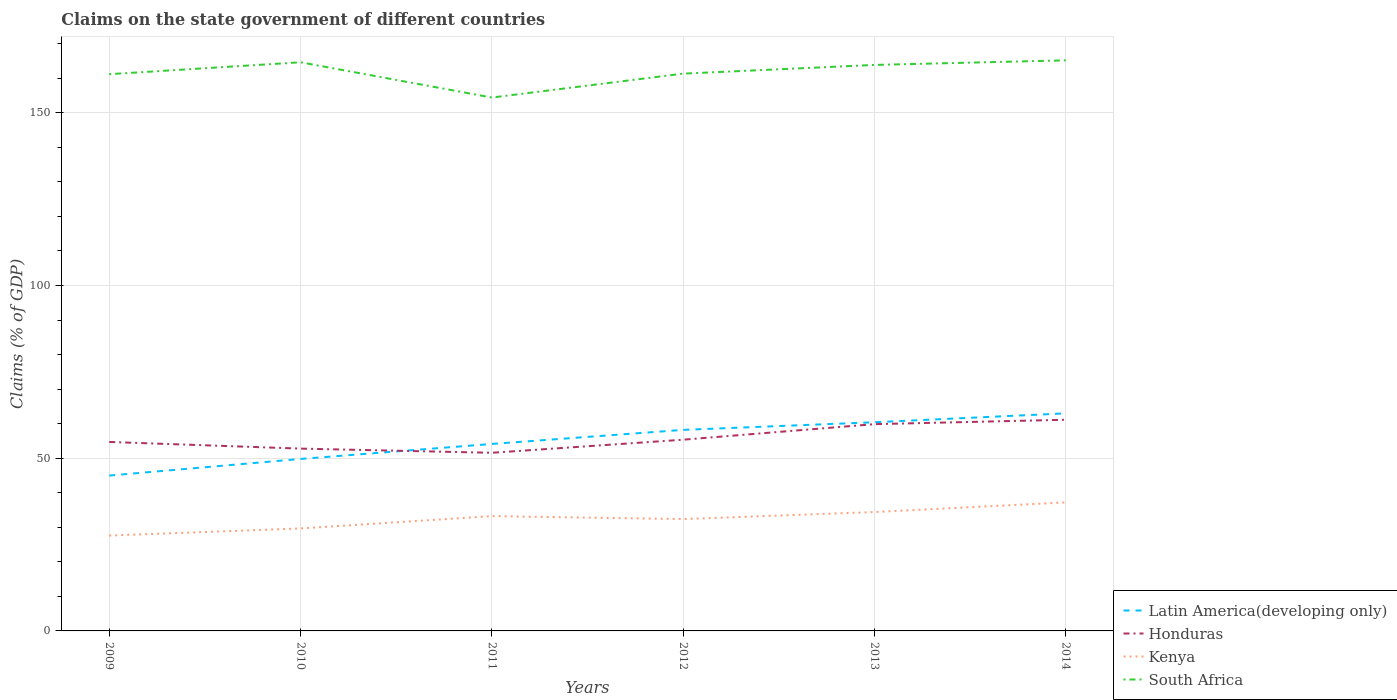How many different coloured lines are there?
Your answer should be compact. 4. Across all years, what is the maximum percentage of GDP claimed on the state government in Kenya?
Your answer should be very brief. 27.61. What is the total percentage of GDP claimed on the state government in Honduras in the graph?
Make the answer very short. -3.79. What is the difference between the highest and the second highest percentage of GDP claimed on the state government in Latin America(developing only)?
Provide a short and direct response. 18.01. What is the difference between the highest and the lowest percentage of GDP claimed on the state government in Latin America(developing only)?
Make the answer very short. 3. How many years are there in the graph?
Your answer should be compact. 6. Does the graph contain grids?
Offer a very short reply. Yes. Where does the legend appear in the graph?
Give a very brief answer. Bottom right. How are the legend labels stacked?
Provide a succinct answer. Vertical. What is the title of the graph?
Make the answer very short. Claims on the state government of different countries. What is the label or title of the X-axis?
Provide a succinct answer. Years. What is the label or title of the Y-axis?
Provide a succinct answer. Claims (% of GDP). What is the Claims (% of GDP) in Latin America(developing only) in 2009?
Provide a short and direct response. 44.98. What is the Claims (% of GDP) of Honduras in 2009?
Keep it short and to the point. 54.71. What is the Claims (% of GDP) of Kenya in 2009?
Keep it short and to the point. 27.61. What is the Claims (% of GDP) of South Africa in 2009?
Provide a short and direct response. 161.18. What is the Claims (% of GDP) in Latin America(developing only) in 2010?
Your answer should be compact. 49.79. What is the Claims (% of GDP) of Honduras in 2010?
Offer a terse response. 52.78. What is the Claims (% of GDP) in Kenya in 2010?
Provide a succinct answer. 29.66. What is the Claims (% of GDP) in South Africa in 2010?
Your answer should be very brief. 164.63. What is the Claims (% of GDP) of Latin America(developing only) in 2011?
Keep it short and to the point. 54.13. What is the Claims (% of GDP) of Honduras in 2011?
Keep it short and to the point. 51.57. What is the Claims (% of GDP) in Kenya in 2011?
Give a very brief answer. 33.23. What is the Claims (% of GDP) of South Africa in 2011?
Provide a short and direct response. 154.42. What is the Claims (% of GDP) in Latin America(developing only) in 2012?
Ensure brevity in your answer.  58.21. What is the Claims (% of GDP) in Honduras in 2012?
Keep it short and to the point. 55.36. What is the Claims (% of GDP) in Kenya in 2012?
Your answer should be compact. 32.39. What is the Claims (% of GDP) of South Africa in 2012?
Offer a terse response. 161.34. What is the Claims (% of GDP) in Latin America(developing only) in 2013?
Keep it short and to the point. 60.41. What is the Claims (% of GDP) in Honduras in 2013?
Your answer should be compact. 59.86. What is the Claims (% of GDP) of Kenya in 2013?
Your response must be concise. 34.42. What is the Claims (% of GDP) of South Africa in 2013?
Your response must be concise. 163.86. What is the Claims (% of GDP) of Latin America(developing only) in 2014?
Your response must be concise. 62.99. What is the Claims (% of GDP) in Honduras in 2014?
Make the answer very short. 61.14. What is the Claims (% of GDP) in Kenya in 2014?
Offer a terse response. 37.21. What is the Claims (% of GDP) in South Africa in 2014?
Your answer should be very brief. 165.19. Across all years, what is the maximum Claims (% of GDP) of Latin America(developing only)?
Keep it short and to the point. 62.99. Across all years, what is the maximum Claims (% of GDP) of Honduras?
Provide a succinct answer. 61.14. Across all years, what is the maximum Claims (% of GDP) of Kenya?
Offer a terse response. 37.21. Across all years, what is the maximum Claims (% of GDP) of South Africa?
Make the answer very short. 165.19. Across all years, what is the minimum Claims (% of GDP) of Latin America(developing only)?
Offer a very short reply. 44.98. Across all years, what is the minimum Claims (% of GDP) in Honduras?
Provide a succinct answer. 51.57. Across all years, what is the minimum Claims (% of GDP) of Kenya?
Your response must be concise. 27.61. Across all years, what is the minimum Claims (% of GDP) of South Africa?
Offer a terse response. 154.42. What is the total Claims (% of GDP) in Latin America(developing only) in the graph?
Keep it short and to the point. 330.51. What is the total Claims (% of GDP) of Honduras in the graph?
Your answer should be very brief. 335.43. What is the total Claims (% of GDP) in Kenya in the graph?
Offer a very short reply. 194.53. What is the total Claims (% of GDP) of South Africa in the graph?
Give a very brief answer. 970.63. What is the difference between the Claims (% of GDP) in Latin America(developing only) in 2009 and that in 2010?
Provide a succinct answer. -4.81. What is the difference between the Claims (% of GDP) in Honduras in 2009 and that in 2010?
Your response must be concise. 1.93. What is the difference between the Claims (% of GDP) in Kenya in 2009 and that in 2010?
Give a very brief answer. -2.05. What is the difference between the Claims (% of GDP) in South Africa in 2009 and that in 2010?
Your response must be concise. -3.45. What is the difference between the Claims (% of GDP) in Latin America(developing only) in 2009 and that in 2011?
Provide a short and direct response. -9.15. What is the difference between the Claims (% of GDP) of Honduras in 2009 and that in 2011?
Your response must be concise. 3.14. What is the difference between the Claims (% of GDP) of Kenya in 2009 and that in 2011?
Your answer should be compact. -5.62. What is the difference between the Claims (% of GDP) of South Africa in 2009 and that in 2011?
Provide a short and direct response. 6.76. What is the difference between the Claims (% of GDP) of Latin America(developing only) in 2009 and that in 2012?
Offer a very short reply. -13.23. What is the difference between the Claims (% of GDP) in Honduras in 2009 and that in 2012?
Ensure brevity in your answer.  -0.65. What is the difference between the Claims (% of GDP) of Kenya in 2009 and that in 2012?
Offer a very short reply. -4.78. What is the difference between the Claims (% of GDP) of South Africa in 2009 and that in 2012?
Make the answer very short. -0.16. What is the difference between the Claims (% of GDP) in Latin America(developing only) in 2009 and that in 2013?
Ensure brevity in your answer.  -15.43. What is the difference between the Claims (% of GDP) of Honduras in 2009 and that in 2013?
Your answer should be compact. -5.16. What is the difference between the Claims (% of GDP) in Kenya in 2009 and that in 2013?
Make the answer very short. -6.81. What is the difference between the Claims (% of GDP) of South Africa in 2009 and that in 2013?
Give a very brief answer. -2.68. What is the difference between the Claims (% of GDP) of Latin America(developing only) in 2009 and that in 2014?
Your response must be concise. -18.01. What is the difference between the Claims (% of GDP) in Honduras in 2009 and that in 2014?
Your response must be concise. -6.43. What is the difference between the Claims (% of GDP) of Kenya in 2009 and that in 2014?
Your answer should be compact. -9.6. What is the difference between the Claims (% of GDP) in South Africa in 2009 and that in 2014?
Provide a succinct answer. -4.01. What is the difference between the Claims (% of GDP) in Latin America(developing only) in 2010 and that in 2011?
Ensure brevity in your answer.  -4.34. What is the difference between the Claims (% of GDP) in Honduras in 2010 and that in 2011?
Keep it short and to the point. 1.21. What is the difference between the Claims (% of GDP) in Kenya in 2010 and that in 2011?
Your response must be concise. -3.57. What is the difference between the Claims (% of GDP) of South Africa in 2010 and that in 2011?
Your answer should be compact. 10.21. What is the difference between the Claims (% of GDP) of Latin America(developing only) in 2010 and that in 2012?
Provide a succinct answer. -8.42. What is the difference between the Claims (% of GDP) of Honduras in 2010 and that in 2012?
Your answer should be compact. -2.58. What is the difference between the Claims (% of GDP) of Kenya in 2010 and that in 2012?
Your answer should be compact. -2.72. What is the difference between the Claims (% of GDP) in South Africa in 2010 and that in 2012?
Your response must be concise. 3.29. What is the difference between the Claims (% of GDP) in Latin America(developing only) in 2010 and that in 2013?
Offer a terse response. -10.63. What is the difference between the Claims (% of GDP) in Honduras in 2010 and that in 2013?
Ensure brevity in your answer.  -7.08. What is the difference between the Claims (% of GDP) in Kenya in 2010 and that in 2013?
Your answer should be compact. -4.75. What is the difference between the Claims (% of GDP) of South Africa in 2010 and that in 2013?
Provide a succinct answer. 0.77. What is the difference between the Claims (% of GDP) in Latin America(developing only) in 2010 and that in 2014?
Provide a short and direct response. -13.2. What is the difference between the Claims (% of GDP) in Honduras in 2010 and that in 2014?
Keep it short and to the point. -8.35. What is the difference between the Claims (% of GDP) in Kenya in 2010 and that in 2014?
Provide a short and direct response. -7.55. What is the difference between the Claims (% of GDP) in South Africa in 2010 and that in 2014?
Keep it short and to the point. -0.56. What is the difference between the Claims (% of GDP) of Latin America(developing only) in 2011 and that in 2012?
Ensure brevity in your answer.  -4.07. What is the difference between the Claims (% of GDP) in Honduras in 2011 and that in 2012?
Keep it short and to the point. -3.79. What is the difference between the Claims (% of GDP) of Kenya in 2011 and that in 2012?
Ensure brevity in your answer.  0.85. What is the difference between the Claims (% of GDP) of South Africa in 2011 and that in 2012?
Provide a short and direct response. -6.92. What is the difference between the Claims (% of GDP) in Latin America(developing only) in 2011 and that in 2013?
Offer a terse response. -6.28. What is the difference between the Claims (% of GDP) in Honduras in 2011 and that in 2013?
Ensure brevity in your answer.  -8.29. What is the difference between the Claims (% of GDP) in Kenya in 2011 and that in 2013?
Make the answer very short. -1.19. What is the difference between the Claims (% of GDP) of South Africa in 2011 and that in 2013?
Offer a terse response. -9.44. What is the difference between the Claims (% of GDP) in Latin America(developing only) in 2011 and that in 2014?
Offer a terse response. -8.86. What is the difference between the Claims (% of GDP) of Honduras in 2011 and that in 2014?
Make the answer very short. -9.56. What is the difference between the Claims (% of GDP) in Kenya in 2011 and that in 2014?
Provide a short and direct response. -3.98. What is the difference between the Claims (% of GDP) in South Africa in 2011 and that in 2014?
Your answer should be very brief. -10.77. What is the difference between the Claims (% of GDP) of Latin America(developing only) in 2012 and that in 2013?
Your answer should be very brief. -2.21. What is the difference between the Claims (% of GDP) in Honduras in 2012 and that in 2013?
Offer a terse response. -4.51. What is the difference between the Claims (% of GDP) of Kenya in 2012 and that in 2013?
Your answer should be very brief. -2.03. What is the difference between the Claims (% of GDP) in South Africa in 2012 and that in 2013?
Your answer should be compact. -2.52. What is the difference between the Claims (% of GDP) of Latin America(developing only) in 2012 and that in 2014?
Your response must be concise. -4.78. What is the difference between the Claims (% of GDP) in Honduras in 2012 and that in 2014?
Offer a very short reply. -5.78. What is the difference between the Claims (% of GDP) of Kenya in 2012 and that in 2014?
Ensure brevity in your answer.  -4.83. What is the difference between the Claims (% of GDP) of South Africa in 2012 and that in 2014?
Ensure brevity in your answer.  -3.85. What is the difference between the Claims (% of GDP) of Latin America(developing only) in 2013 and that in 2014?
Provide a succinct answer. -2.58. What is the difference between the Claims (% of GDP) of Honduras in 2013 and that in 2014?
Give a very brief answer. -1.27. What is the difference between the Claims (% of GDP) in Kenya in 2013 and that in 2014?
Give a very brief answer. -2.79. What is the difference between the Claims (% of GDP) of South Africa in 2013 and that in 2014?
Give a very brief answer. -1.33. What is the difference between the Claims (% of GDP) in Latin America(developing only) in 2009 and the Claims (% of GDP) in Honduras in 2010?
Make the answer very short. -7.8. What is the difference between the Claims (% of GDP) in Latin America(developing only) in 2009 and the Claims (% of GDP) in Kenya in 2010?
Ensure brevity in your answer.  15.32. What is the difference between the Claims (% of GDP) of Latin America(developing only) in 2009 and the Claims (% of GDP) of South Africa in 2010?
Your response must be concise. -119.65. What is the difference between the Claims (% of GDP) in Honduras in 2009 and the Claims (% of GDP) in Kenya in 2010?
Your answer should be compact. 25.05. What is the difference between the Claims (% of GDP) in Honduras in 2009 and the Claims (% of GDP) in South Africa in 2010?
Give a very brief answer. -109.92. What is the difference between the Claims (% of GDP) in Kenya in 2009 and the Claims (% of GDP) in South Africa in 2010?
Provide a short and direct response. -137.02. What is the difference between the Claims (% of GDP) of Latin America(developing only) in 2009 and the Claims (% of GDP) of Honduras in 2011?
Give a very brief answer. -6.59. What is the difference between the Claims (% of GDP) of Latin America(developing only) in 2009 and the Claims (% of GDP) of Kenya in 2011?
Provide a short and direct response. 11.75. What is the difference between the Claims (% of GDP) of Latin America(developing only) in 2009 and the Claims (% of GDP) of South Africa in 2011?
Provide a succinct answer. -109.44. What is the difference between the Claims (% of GDP) in Honduras in 2009 and the Claims (% of GDP) in Kenya in 2011?
Give a very brief answer. 21.48. What is the difference between the Claims (% of GDP) of Honduras in 2009 and the Claims (% of GDP) of South Africa in 2011?
Offer a very short reply. -99.71. What is the difference between the Claims (% of GDP) of Kenya in 2009 and the Claims (% of GDP) of South Africa in 2011?
Ensure brevity in your answer.  -126.81. What is the difference between the Claims (% of GDP) in Latin America(developing only) in 2009 and the Claims (% of GDP) in Honduras in 2012?
Make the answer very short. -10.38. What is the difference between the Claims (% of GDP) in Latin America(developing only) in 2009 and the Claims (% of GDP) in Kenya in 2012?
Offer a very short reply. 12.59. What is the difference between the Claims (% of GDP) of Latin America(developing only) in 2009 and the Claims (% of GDP) of South Africa in 2012?
Your answer should be very brief. -116.36. What is the difference between the Claims (% of GDP) in Honduras in 2009 and the Claims (% of GDP) in Kenya in 2012?
Provide a short and direct response. 22.32. What is the difference between the Claims (% of GDP) in Honduras in 2009 and the Claims (% of GDP) in South Africa in 2012?
Make the answer very short. -106.63. What is the difference between the Claims (% of GDP) in Kenya in 2009 and the Claims (% of GDP) in South Africa in 2012?
Offer a terse response. -133.73. What is the difference between the Claims (% of GDP) of Latin America(developing only) in 2009 and the Claims (% of GDP) of Honduras in 2013?
Keep it short and to the point. -14.89. What is the difference between the Claims (% of GDP) in Latin America(developing only) in 2009 and the Claims (% of GDP) in Kenya in 2013?
Your answer should be very brief. 10.56. What is the difference between the Claims (% of GDP) of Latin America(developing only) in 2009 and the Claims (% of GDP) of South Africa in 2013?
Make the answer very short. -118.88. What is the difference between the Claims (% of GDP) in Honduras in 2009 and the Claims (% of GDP) in Kenya in 2013?
Provide a short and direct response. 20.29. What is the difference between the Claims (% of GDP) in Honduras in 2009 and the Claims (% of GDP) in South Africa in 2013?
Offer a terse response. -109.15. What is the difference between the Claims (% of GDP) of Kenya in 2009 and the Claims (% of GDP) of South Africa in 2013?
Keep it short and to the point. -136.25. What is the difference between the Claims (% of GDP) of Latin America(developing only) in 2009 and the Claims (% of GDP) of Honduras in 2014?
Your answer should be compact. -16.16. What is the difference between the Claims (% of GDP) of Latin America(developing only) in 2009 and the Claims (% of GDP) of Kenya in 2014?
Provide a succinct answer. 7.77. What is the difference between the Claims (% of GDP) of Latin America(developing only) in 2009 and the Claims (% of GDP) of South Africa in 2014?
Your answer should be compact. -120.21. What is the difference between the Claims (% of GDP) of Honduras in 2009 and the Claims (% of GDP) of Kenya in 2014?
Your response must be concise. 17.5. What is the difference between the Claims (% of GDP) of Honduras in 2009 and the Claims (% of GDP) of South Africa in 2014?
Keep it short and to the point. -110.48. What is the difference between the Claims (% of GDP) in Kenya in 2009 and the Claims (% of GDP) in South Africa in 2014?
Your response must be concise. -137.58. What is the difference between the Claims (% of GDP) in Latin America(developing only) in 2010 and the Claims (% of GDP) in Honduras in 2011?
Keep it short and to the point. -1.79. What is the difference between the Claims (% of GDP) in Latin America(developing only) in 2010 and the Claims (% of GDP) in Kenya in 2011?
Make the answer very short. 16.56. What is the difference between the Claims (% of GDP) in Latin America(developing only) in 2010 and the Claims (% of GDP) in South Africa in 2011?
Your answer should be very brief. -104.63. What is the difference between the Claims (% of GDP) of Honduras in 2010 and the Claims (% of GDP) of Kenya in 2011?
Your response must be concise. 19.55. What is the difference between the Claims (% of GDP) in Honduras in 2010 and the Claims (% of GDP) in South Africa in 2011?
Your answer should be very brief. -101.64. What is the difference between the Claims (% of GDP) in Kenya in 2010 and the Claims (% of GDP) in South Africa in 2011?
Offer a very short reply. -124.75. What is the difference between the Claims (% of GDP) in Latin America(developing only) in 2010 and the Claims (% of GDP) in Honduras in 2012?
Your answer should be compact. -5.57. What is the difference between the Claims (% of GDP) in Latin America(developing only) in 2010 and the Claims (% of GDP) in Kenya in 2012?
Offer a terse response. 17.4. What is the difference between the Claims (% of GDP) in Latin America(developing only) in 2010 and the Claims (% of GDP) in South Africa in 2012?
Your response must be concise. -111.55. What is the difference between the Claims (% of GDP) of Honduras in 2010 and the Claims (% of GDP) of Kenya in 2012?
Your answer should be very brief. 20.4. What is the difference between the Claims (% of GDP) in Honduras in 2010 and the Claims (% of GDP) in South Africa in 2012?
Make the answer very short. -108.56. What is the difference between the Claims (% of GDP) of Kenya in 2010 and the Claims (% of GDP) of South Africa in 2012?
Provide a succinct answer. -131.67. What is the difference between the Claims (% of GDP) in Latin America(developing only) in 2010 and the Claims (% of GDP) in Honduras in 2013?
Offer a very short reply. -10.08. What is the difference between the Claims (% of GDP) in Latin America(developing only) in 2010 and the Claims (% of GDP) in Kenya in 2013?
Ensure brevity in your answer.  15.37. What is the difference between the Claims (% of GDP) of Latin America(developing only) in 2010 and the Claims (% of GDP) of South Africa in 2013?
Make the answer very short. -114.08. What is the difference between the Claims (% of GDP) in Honduras in 2010 and the Claims (% of GDP) in Kenya in 2013?
Provide a short and direct response. 18.36. What is the difference between the Claims (% of GDP) in Honduras in 2010 and the Claims (% of GDP) in South Africa in 2013?
Your answer should be very brief. -111.08. What is the difference between the Claims (% of GDP) of Kenya in 2010 and the Claims (% of GDP) of South Africa in 2013?
Offer a terse response. -134.2. What is the difference between the Claims (% of GDP) in Latin America(developing only) in 2010 and the Claims (% of GDP) in Honduras in 2014?
Your answer should be compact. -11.35. What is the difference between the Claims (% of GDP) of Latin America(developing only) in 2010 and the Claims (% of GDP) of Kenya in 2014?
Offer a terse response. 12.58. What is the difference between the Claims (% of GDP) of Latin America(developing only) in 2010 and the Claims (% of GDP) of South Africa in 2014?
Offer a terse response. -115.4. What is the difference between the Claims (% of GDP) of Honduras in 2010 and the Claims (% of GDP) of Kenya in 2014?
Ensure brevity in your answer.  15.57. What is the difference between the Claims (% of GDP) in Honduras in 2010 and the Claims (% of GDP) in South Africa in 2014?
Give a very brief answer. -112.41. What is the difference between the Claims (% of GDP) in Kenya in 2010 and the Claims (% of GDP) in South Africa in 2014?
Your answer should be very brief. -135.53. What is the difference between the Claims (% of GDP) of Latin America(developing only) in 2011 and the Claims (% of GDP) of Honduras in 2012?
Your response must be concise. -1.23. What is the difference between the Claims (% of GDP) in Latin America(developing only) in 2011 and the Claims (% of GDP) in Kenya in 2012?
Your answer should be very brief. 21.75. What is the difference between the Claims (% of GDP) in Latin America(developing only) in 2011 and the Claims (% of GDP) in South Africa in 2012?
Your answer should be very brief. -107.21. What is the difference between the Claims (% of GDP) of Honduras in 2011 and the Claims (% of GDP) of Kenya in 2012?
Give a very brief answer. 19.19. What is the difference between the Claims (% of GDP) of Honduras in 2011 and the Claims (% of GDP) of South Africa in 2012?
Offer a terse response. -109.76. What is the difference between the Claims (% of GDP) of Kenya in 2011 and the Claims (% of GDP) of South Africa in 2012?
Give a very brief answer. -128.11. What is the difference between the Claims (% of GDP) in Latin America(developing only) in 2011 and the Claims (% of GDP) in Honduras in 2013?
Give a very brief answer. -5.73. What is the difference between the Claims (% of GDP) in Latin America(developing only) in 2011 and the Claims (% of GDP) in Kenya in 2013?
Give a very brief answer. 19.71. What is the difference between the Claims (% of GDP) in Latin America(developing only) in 2011 and the Claims (% of GDP) in South Africa in 2013?
Provide a succinct answer. -109.73. What is the difference between the Claims (% of GDP) in Honduras in 2011 and the Claims (% of GDP) in Kenya in 2013?
Provide a succinct answer. 17.16. What is the difference between the Claims (% of GDP) of Honduras in 2011 and the Claims (% of GDP) of South Africa in 2013?
Your response must be concise. -112.29. What is the difference between the Claims (% of GDP) in Kenya in 2011 and the Claims (% of GDP) in South Africa in 2013?
Give a very brief answer. -130.63. What is the difference between the Claims (% of GDP) in Latin America(developing only) in 2011 and the Claims (% of GDP) in Honduras in 2014?
Provide a succinct answer. -7. What is the difference between the Claims (% of GDP) of Latin America(developing only) in 2011 and the Claims (% of GDP) of Kenya in 2014?
Give a very brief answer. 16.92. What is the difference between the Claims (% of GDP) in Latin America(developing only) in 2011 and the Claims (% of GDP) in South Africa in 2014?
Your response must be concise. -111.06. What is the difference between the Claims (% of GDP) in Honduras in 2011 and the Claims (% of GDP) in Kenya in 2014?
Give a very brief answer. 14.36. What is the difference between the Claims (% of GDP) of Honduras in 2011 and the Claims (% of GDP) of South Africa in 2014?
Give a very brief answer. -113.62. What is the difference between the Claims (% of GDP) in Kenya in 2011 and the Claims (% of GDP) in South Africa in 2014?
Your answer should be very brief. -131.96. What is the difference between the Claims (% of GDP) in Latin America(developing only) in 2012 and the Claims (% of GDP) in Honduras in 2013?
Provide a short and direct response. -1.66. What is the difference between the Claims (% of GDP) in Latin America(developing only) in 2012 and the Claims (% of GDP) in Kenya in 2013?
Give a very brief answer. 23.79. What is the difference between the Claims (% of GDP) of Latin America(developing only) in 2012 and the Claims (% of GDP) of South Africa in 2013?
Ensure brevity in your answer.  -105.66. What is the difference between the Claims (% of GDP) of Honduras in 2012 and the Claims (% of GDP) of Kenya in 2013?
Keep it short and to the point. 20.94. What is the difference between the Claims (% of GDP) of Honduras in 2012 and the Claims (% of GDP) of South Africa in 2013?
Your answer should be very brief. -108.5. What is the difference between the Claims (% of GDP) in Kenya in 2012 and the Claims (% of GDP) in South Africa in 2013?
Your answer should be very brief. -131.48. What is the difference between the Claims (% of GDP) of Latin America(developing only) in 2012 and the Claims (% of GDP) of Honduras in 2014?
Your response must be concise. -2.93. What is the difference between the Claims (% of GDP) of Latin America(developing only) in 2012 and the Claims (% of GDP) of Kenya in 2014?
Your response must be concise. 20.99. What is the difference between the Claims (% of GDP) of Latin America(developing only) in 2012 and the Claims (% of GDP) of South Africa in 2014?
Your answer should be compact. -106.99. What is the difference between the Claims (% of GDP) in Honduras in 2012 and the Claims (% of GDP) in Kenya in 2014?
Keep it short and to the point. 18.15. What is the difference between the Claims (% of GDP) of Honduras in 2012 and the Claims (% of GDP) of South Africa in 2014?
Offer a very short reply. -109.83. What is the difference between the Claims (% of GDP) of Kenya in 2012 and the Claims (% of GDP) of South Africa in 2014?
Keep it short and to the point. -132.81. What is the difference between the Claims (% of GDP) in Latin America(developing only) in 2013 and the Claims (% of GDP) in Honduras in 2014?
Keep it short and to the point. -0.72. What is the difference between the Claims (% of GDP) of Latin America(developing only) in 2013 and the Claims (% of GDP) of Kenya in 2014?
Provide a short and direct response. 23.2. What is the difference between the Claims (% of GDP) of Latin America(developing only) in 2013 and the Claims (% of GDP) of South Africa in 2014?
Offer a terse response. -104.78. What is the difference between the Claims (% of GDP) in Honduras in 2013 and the Claims (% of GDP) in Kenya in 2014?
Your answer should be very brief. 22.65. What is the difference between the Claims (% of GDP) of Honduras in 2013 and the Claims (% of GDP) of South Africa in 2014?
Your answer should be compact. -105.33. What is the difference between the Claims (% of GDP) of Kenya in 2013 and the Claims (% of GDP) of South Africa in 2014?
Provide a succinct answer. -130.77. What is the average Claims (% of GDP) of Latin America(developing only) per year?
Make the answer very short. 55.09. What is the average Claims (% of GDP) in Honduras per year?
Ensure brevity in your answer.  55.9. What is the average Claims (% of GDP) in Kenya per year?
Offer a very short reply. 32.42. What is the average Claims (% of GDP) in South Africa per year?
Ensure brevity in your answer.  161.77. In the year 2009, what is the difference between the Claims (% of GDP) in Latin America(developing only) and Claims (% of GDP) in Honduras?
Your response must be concise. -9.73. In the year 2009, what is the difference between the Claims (% of GDP) in Latin America(developing only) and Claims (% of GDP) in Kenya?
Your answer should be very brief. 17.37. In the year 2009, what is the difference between the Claims (% of GDP) of Latin America(developing only) and Claims (% of GDP) of South Africa?
Your response must be concise. -116.2. In the year 2009, what is the difference between the Claims (% of GDP) in Honduras and Claims (% of GDP) in Kenya?
Offer a terse response. 27.1. In the year 2009, what is the difference between the Claims (% of GDP) of Honduras and Claims (% of GDP) of South Africa?
Provide a succinct answer. -106.47. In the year 2009, what is the difference between the Claims (% of GDP) in Kenya and Claims (% of GDP) in South Africa?
Keep it short and to the point. -133.57. In the year 2010, what is the difference between the Claims (% of GDP) in Latin America(developing only) and Claims (% of GDP) in Honduras?
Your answer should be compact. -2.99. In the year 2010, what is the difference between the Claims (% of GDP) in Latin America(developing only) and Claims (% of GDP) in Kenya?
Keep it short and to the point. 20.12. In the year 2010, what is the difference between the Claims (% of GDP) in Latin America(developing only) and Claims (% of GDP) in South Africa?
Provide a succinct answer. -114.84. In the year 2010, what is the difference between the Claims (% of GDP) of Honduras and Claims (% of GDP) of Kenya?
Provide a succinct answer. 23.12. In the year 2010, what is the difference between the Claims (% of GDP) in Honduras and Claims (% of GDP) in South Africa?
Keep it short and to the point. -111.85. In the year 2010, what is the difference between the Claims (% of GDP) in Kenya and Claims (% of GDP) in South Africa?
Ensure brevity in your answer.  -134.97. In the year 2011, what is the difference between the Claims (% of GDP) in Latin America(developing only) and Claims (% of GDP) in Honduras?
Your response must be concise. 2.56. In the year 2011, what is the difference between the Claims (% of GDP) of Latin America(developing only) and Claims (% of GDP) of Kenya?
Offer a very short reply. 20.9. In the year 2011, what is the difference between the Claims (% of GDP) in Latin America(developing only) and Claims (% of GDP) in South Africa?
Provide a succinct answer. -100.29. In the year 2011, what is the difference between the Claims (% of GDP) in Honduras and Claims (% of GDP) in Kenya?
Your answer should be very brief. 18.34. In the year 2011, what is the difference between the Claims (% of GDP) in Honduras and Claims (% of GDP) in South Africa?
Ensure brevity in your answer.  -102.84. In the year 2011, what is the difference between the Claims (% of GDP) in Kenya and Claims (% of GDP) in South Africa?
Give a very brief answer. -121.19. In the year 2012, what is the difference between the Claims (% of GDP) of Latin America(developing only) and Claims (% of GDP) of Honduras?
Your answer should be very brief. 2.85. In the year 2012, what is the difference between the Claims (% of GDP) in Latin America(developing only) and Claims (% of GDP) in Kenya?
Keep it short and to the point. 25.82. In the year 2012, what is the difference between the Claims (% of GDP) in Latin America(developing only) and Claims (% of GDP) in South Africa?
Your answer should be compact. -103.13. In the year 2012, what is the difference between the Claims (% of GDP) in Honduras and Claims (% of GDP) in Kenya?
Provide a succinct answer. 22.97. In the year 2012, what is the difference between the Claims (% of GDP) of Honduras and Claims (% of GDP) of South Africa?
Give a very brief answer. -105.98. In the year 2012, what is the difference between the Claims (% of GDP) in Kenya and Claims (% of GDP) in South Africa?
Give a very brief answer. -128.95. In the year 2013, what is the difference between the Claims (% of GDP) in Latin America(developing only) and Claims (% of GDP) in Honduras?
Your response must be concise. 0.55. In the year 2013, what is the difference between the Claims (% of GDP) of Latin America(developing only) and Claims (% of GDP) of Kenya?
Ensure brevity in your answer.  26. In the year 2013, what is the difference between the Claims (% of GDP) of Latin America(developing only) and Claims (% of GDP) of South Africa?
Provide a succinct answer. -103.45. In the year 2013, what is the difference between the Claims (% of GDP) of Honduras and Claims (% of GDP) of Kenya?
Your answer should be very brief. 25.45. In the year 2013, what is the difference between the Claims (% of GDP) of Honduras and Claims (% of GDP) of South Africa?
Provide a short and direct response. -104. In the year 2013, what is the difference between the Claims (% of GDP) in Kenya and Claims (% of GDP) in South Africa?
Your answer should be compact. -129.44. In the year 2014, what is the difference between the Claims (% of GDP) in Latin America(developing only) and Claims (% of GDP) in Honduras?
Make the answer very short. 1.85. In the year 2014, what is the difference between the Claims (% of GDP) of Latin America(developing only) and Claims (% of GDP) of Kenya?
Provide a short and direct response. 25.78. In the year 2014, what is the difference between the Claims (% of GDP) in Latin America(developing only) and Claims (% of GDP) in South Africa?
Ensure brevity in your answer.  -102.2. In the year 2014, what is the difference between the Claims (% of GDP) in Honduras and Claims (% of GDP) in Kenya?
Your answer should be very brief. 23.92. In the year 2014, what is the difference between the Claims (% of GDP) of Honduras and Claims (% of GDP) of South Africa?
Offer a very short reply. -104.06. In the year 2014, what is the difference between the Claims (% of GDP) in Kenya and Claims (% of GDP) in South Africa?
Your answer should be compact. -127.98. What is the ratio of the Claims (% of GDP) in Latin America(developing only) in 2009 to that in 2010?
Your answer should be compact. 0.9. What is the ratio of the Claims (% of GDP) of Honduras in 2009 to that in 2010?
Offer a terse response. 1.04. What is the ratio of the Claims (% of GDP) in Kenya in 2009 to that in 2010?
Provide a short and direct response. 0.93. What is the ratio of the Claims (% of GDP) of South Africa in 2009 to that in 2010?
Make the answer very short. 0.98. What is the ratio of the Claims (% of GDP) in Latin America(developing only) in 2009 to that in 2011?
Provide a short and direct response. 0.83. What is the ratio of the Claims (% of GDP) of Honduras in 2009 to that in 2011?
Provide a succinct answer. 1.06. What is the ratio of the Claims (% of GDP) in Kenya in 2009 to that in 2011?
Your answer should be compact. 0.83. What is the ratio of the Claims (% of GDP) of South Africa in 2009 to that in 2011?
Your answer should be compact. 1.04. What is the ratio of the Claims (% of GDP) in Latin America(developing only) in 2009 to that in 2012?
Keep it short and to the point. 0.77. What is the ratio of the Claims (% of GDP) of Honduras in 2009 to that in 2012?
Keep it short and to the point. 0.99. What is the ratio of the Claims (% of GDP) in Kenya in 2009 to that in 2012?
Make the answer very short. 0.85. What is the ratio of the Claims (% of GDP) in South Africa in 2009 to that in 2012?
Ensure brevity in your answer.  1. What is the ratio of the Claims (% of GDP) in Latin America(developing only) in 2009 to that in 2013?
Your response must be concise. 0.74. What is the ratio of the Claims (% of GDP) of Honduras in 2009 to that in 2013?
Your answer should be compact. 0.91. What is the ratio of the Claims (% of GDP) in Kenya in 2009 to that in 2013?
Provide a succinct answer. 0.8. What is the ratio of the Claims (% of GDP) in South Africa in 2009 to that in 2013?
Keep it short and to the point. 0.98. What is the ratio of the Claims (% of GDP) of Latin America(developing only) in 2009 to that in 2014?
Offer a very short reply. 0.71. What is the ratio of the Claims (% of GDP) of Honduras in 2009 to that in 2014?
Your answer should be compact. 0.89. What is the ratio of the Claims (% of GDP) of Kenya in 2009 to that in 2014?
Make the answer very short. 0.74. What is the ratio of the Claims (% of GDP) of South Africa in 2009 to that in 2014?
Offer a very short reply. 0.98. What is the ratio of the Claims (% of GDP) in Latin America(developing only) in 2010 to that in 2011?
Your answer should be compact. 0.92. What is the ratio of the Claims (% of GDP) of Honduras in 2010 to that in 2011?
Provide a succinct answer. 1.02. What is the ratio of the Claims (% of GDP) in Kenya in 2010 to that in 2011?
Your answer should be compact. 0.89. What is the ratio of the Claims (% of GDP) in South Africa in 2010 to that in 2011?
Your response must be concise. 1.07. What is the ratio of the Claims (% of GDP) of Latin America(developing only) in 2010 to that in 2012?
Give a very brief answer. 0.86. What is the ratio of the Claims (% of GDP) in Honduras in 2010 to that in 2012?
Provide a succinct answer. 0.95. What is the ratio of the Claims (% of GDP) in Kenya in 2010 to that in 2012?
Make the answer very short. 0.92. What is the ratio of the Claims (% of GDP) of South Africa in 2010 to that in 2012?
Provide a short and direct response. 1.02. What is the ratio of the Claims (% of GDP) in Latin America(developing only) in 2010 to that in 2013?
Make the answer very short. 0.82. What is the ratio of the Claims (% of GDP) in Honduras in 2010 to that in 2013?
Keep it short and to the point. 0.88. What is the ratio of the Claims (% of GDP) of Kenya in 2010 to that in 2013?
Make the answer very short. 0.86. What is the ratio of the Claims (% of GDP) in South Africa in 2010 to that in 2013?
Offer a very short reply. 1. What is the ratio of the Claims (% of GDP) of Latin America(developing only) in 2010 to that in 2014?
Provide a short and direct response. 0.79. What is the ratio of the Claims (% of GDP) in Honduras in 2010 to that in 2014?
Your answer should be very brief. 0.86. What is the ratio of the Claims (% of GDP) of Kenya in 2010 to that in 2014?
Your answer should be compact. 0.8. What is the ratio of the Claims (% of GDP) of South Africa in 2010 to that in 2014?
Your answer should be compact. 1. What is the ratio of the Claims (% of GDP) of Latin America(developing only) in 2011 to that in 2012?
Keep it short and to the point. 0.93. What is the ratio of the Claims (% of GDP) in Honduras in 2011 to that in 2012?
Your answer should be compact. 0.93. What is the ratio of the Claims (% of GDP) of Kenya in 2011 to that in 2012?
Offer a terse response. 1.03. What is the ratio of the Claims (% of GDP) in South Africa in 2011 to that in 2012?
Provide a succinct answer. 0.96. What is the ratio of the Claims (% of GDP) of Latin America(developing only) in 2011 to that in 2013?
Make the answer very short. 0.9. What is the ratio of the Claims (% of GDP) in Honduras in 2011 to that in 2013?
Ensure brevity in your answer.  0.86. What is the ratio of the Claims (% of GDP) in Kenya in 2011 to that in 2013?
Keep it short and to the point. 0.97. What is the ratio of the Claims (% of GDP) of South Africa in 2011 to that in 2013?
Your answer should be compact. 0.94. What is the ratio of the Claims (% of GDP) in Latin America(developing only) in 2011 to that in 2014?
Provide a succinct answer. 0.86. What is the ratio of the Claims (% of GDP) in Honduras in 2011 to that in 2014?
Your response must be concise. 0.84. What is the ratio of the Claims (% of GDP) in Kenya in 2011 to that in 2014?
Your answer should be compact. 0.89. What is the ratio of the Claims (% of GDP) of South Africa in 2011 to that in 2014?
Your answer should be very brief. 0.93. What is the ratio of the Claims (% of GDP) of Latin America(developing only) in 2012 to that in 2013?
Your answer should be very brief. 0.96. What is the ratio of the Claims (% of GDP) in Honduras in 2012 to that in 2013?
Give a very brief answer. 0.92. What is the ratio of the Claims (% of GDP) of Kenya in 2012 to that in 2013?
Give a very brief answer. 0.94. What is the ratio of the Claims (% of GDP) in South Africa in 2012 to that in 2013?
Provide a short and direct response. 0.98. What is the ratio of the Claims (% of GDP) in Latin America(developing only) in 2012 to that in 2014?
Your answer should be compact. 0.92. What is the ratio of the Claims (% of GDP) of Honduras in 2012 to that in 2014?
Give a very brief answer. 0.91. What is the ratio of the Claims (% of GDP) of Kenya in 2012 to that in 2014?
Offer a very short reply. 0.87. What is the ratio of the Claims (% of GDP) in South Africa in 2012 to that in 2014?
Offer a terse response. 0.98. What is the ratio of the Claims (% of GDP) in Latin America(developing only) in 2013 to that in 2014?
Make the answer very short. 0.96. What is the ratio of the Claims (% of GDP) of Honduras in 2013 to that in 2014?
Provide a short and direct response. 0.98. What is the ratio of the Claims (% of GDP) in Kenya in 2013 to that in 2014?
Make the answer very short. 0.92. What is the ratio of the Claims (% of GDP) of South Africa in 2013 to that in 2014?
Give a very brief answer. 0.99. What is the difference between the highest and the second highest Claims (% of GDP) of Latin America(developing only)?
Keep it short and to the point. 2.58. What is the difference between the highest and the second highest Claims (% of GDP) in Honduras?
Make the answer very short. 1.27. What is the difference between the highest and the second highest Claims (% of GDP) in Kenya?
Your answer should be compact. 2.79. What is the difference between the highest and the second highest Claims (% of GDP) of South Africa?
Make the answer very short. 0.56. What is the difference between the highest and the lowest Claims (% of GDP) of Latin America(developing only)?
Make the answer very short. 18.01. What is the difference between the highest and the lowest Claims (% of GDP) in Honduras?
Make the answer very short. 9.56. What is the difference between the highest and the lowest Claims (% of GDP) in Kenya?
Keep it short and to the point. 9.6. What is the difference between the highest and the lowest Claims (% of GDP) of South Africa?
Provide a short and direct response. 10.77. 